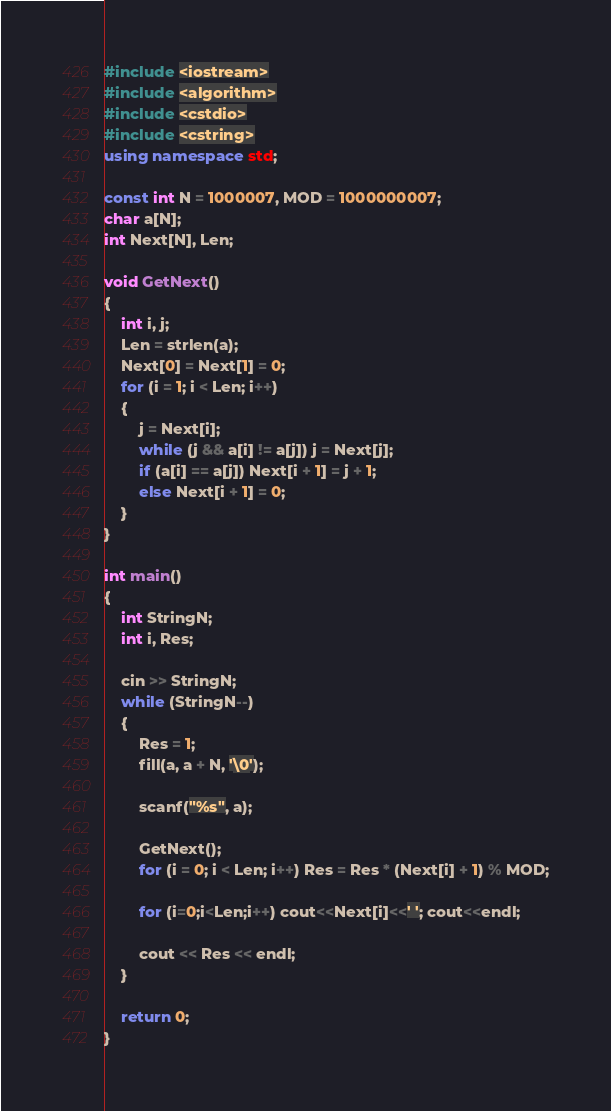Convert code to text. <code><loc_0><loc_0><loc_500><loc_500><_C++_>#include <iostream>
#include <algorithm>
#include <cstdio>
#include <cstring>
using namespace std;

const int N = 1000007, MOD = 1000000007;
char a[N];
int Next[N], Len;

void GetNext()
{
	int i, j;
	Len = strlen(a);
	Next[0] = Next[1] = 0;
	for (i = 1; i < Len; i++)
	{
		j = Next[i];
		while (j && a[i] != a[j]) j = Next[j];
		if (a[i] == a[j]) Next[i + 1] = j + 1;
		else Next[i + 1] = 0;
	}
}

int main()
{
	int StringN;
	int i, Res;
	
	cin >> StringN;
	while (StringN--)
	{
		Res = 1;
		fill(a, a + N, '\0');
		
		scanf("%s", a);
		
		GetNext();
		for (i = 0; i < Len; i++) Res = Res * (Next[i] + 1) % MOD;
		
		for (i=0;i<Len;i++) cout<<Next[i]<<' '; cout<<endl;
		
		cout << Res << endl;
	}
	
	return 0;
}

</code> 